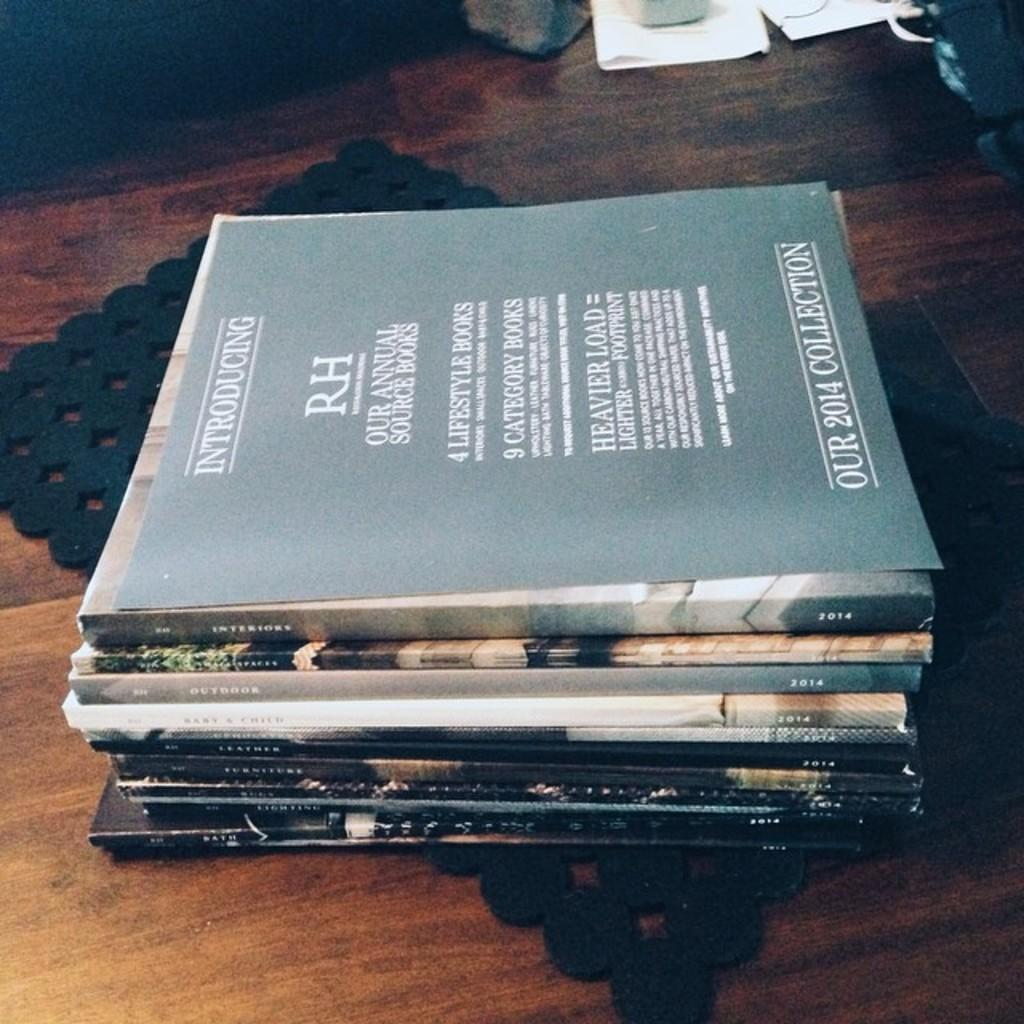<image>
Describe the image concisely. A stack of books sits on a desk with Our 2014 Collection on top 